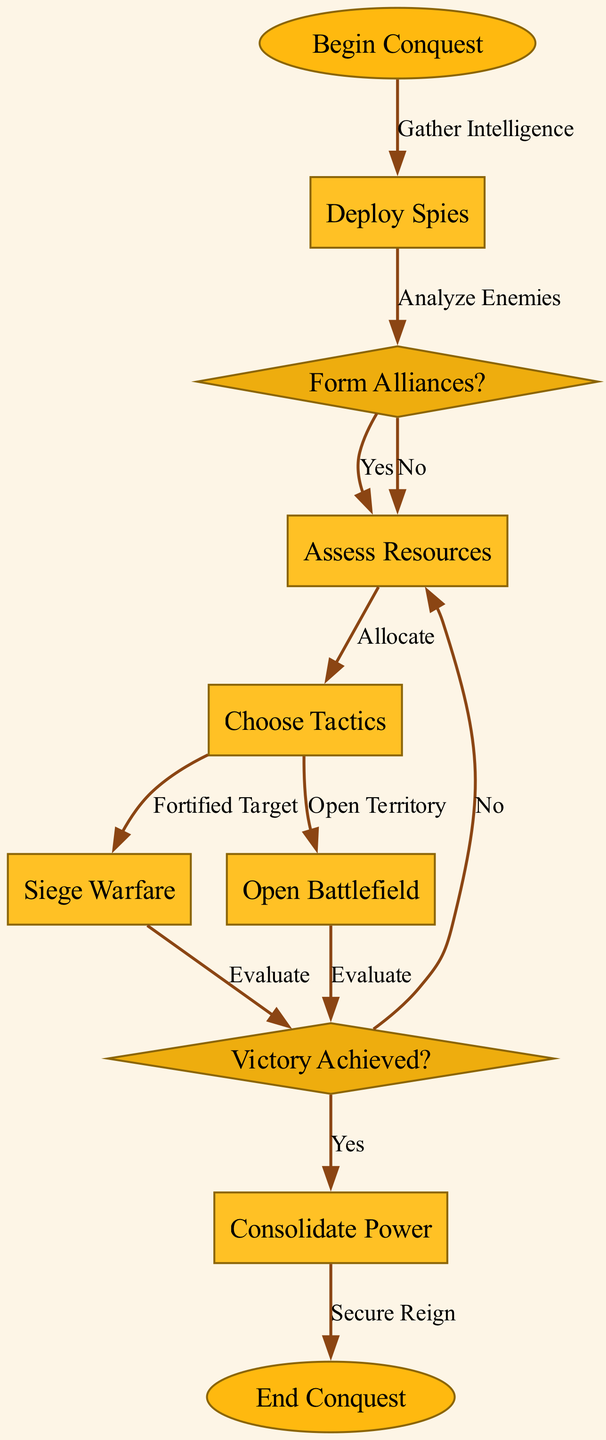What is the first step in the conquest strategy? The diagram begins with the node labeled "Begin Conquest," indicating that this is the first action taken in the flowchart.
Answer: Begin Conquest How many nodes are present in the diagram? By counting the nodes in the diagram, there are a total of ten distinct nodes involved in the conquest strategy.
Answer: 10 What decision follows the analysis of enemies? After analyzing enemies, the next decision is whether to form alliances, represented by the node labeled "Form Alliances?"
Answer: Form Alliances? If alliances are not formed, what is the next step? From the node labeled "Form Alliances?", if the answer is "No," the flowchart shows that it leads directly to the node labeled "Assess Resources."
Answer: Assess Resources Which military tactic is chosen for a fortified target? The diagram indicates that if a fortified target is chosen, the next military tactic would be "Siege Warfare," resulting in the connected node labeled "Siege Warfare."
Answer: Siege Warfare How does one achieve victory after siege warfare? From the node labeled "Siege Warfare," the flow leads to the "Evaluate" node, where the outcome of the siege is assessed to determine if victory is achieved.
Answer: Evaluate What happens if the evaluation of victory results in "No"? According to the diagram, if victory is not achieved after evaluation, it leads back to the node labeled "Assess Resources" for further resource assessment.
Answer: Assess Resources What is the final step after consolidating power? The last step in the conquest strategy, once power has been consolidated, is represented by the node labeled "End Conquest."
Answer: End Conquest How many decision points are present in the diagram? By analyzing the diagram, there are four decision points: the nodes labeled "Form Alliances?" and "Evaluate" for different conditions.
Answer: 4 